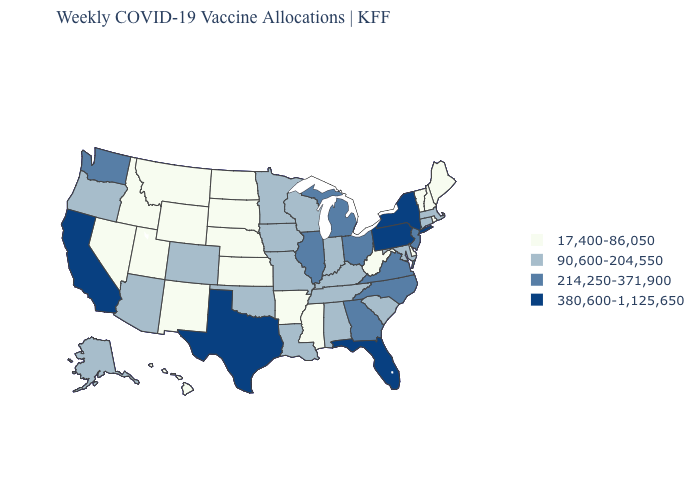What is the lowest value in the South?
Write a very short answer. 17,400-86,050. What is the value of West Virginia?
Concise answer only. 17,400-86,050. Does Indiana have a higher value than North Dakota?
Give a very brief answer. Yes. What is the value of Wisconsin?
Concise answer only. 90,600-204,550. Which states have the highest value in the USA?
Be succinct. California, Florida, New York, Pennsylvania, Texas. Does Alaska have the highest value in the USA?
Keep it brief. No. Name the states that have a value in the range 380,600-1,125,650?
Keep it brief. California, Florida, New York, Pennsylvania, Texas. Among the states that border Nebraska , does Iowa have the highest value?
Concise answer only. Yes. Name the states that have a value in the range 17,400-86,050?
Be succinct. Arkansas, Delaware, Hawaii, Idaho, Kansas, Maine, Mississippi, Montana, Nebraska, Nevada, New Hampshire, New Mexico, North Dakota, Rhode Island, South Dakota, Utah, Vermont, West Virginia, Wyoming. Among the states that border Mississippi , which have the lowest value?
Give a very brief answer. Arkansas. What is the value of Idaho?
Write a very short answer. 17,400-86,050. Which states hav the highest value in the West?
Write a very short answer. California. Which states have the highest value in the USA?
Keep it brief. California, Florida, New York, Pennsylvania, Texas. Does North Carolina have the highest value in the South?
Keep it brief. No. Among the states that border Utah , which have the highest value?
Write a very short answer. Arizona, Colorado. 